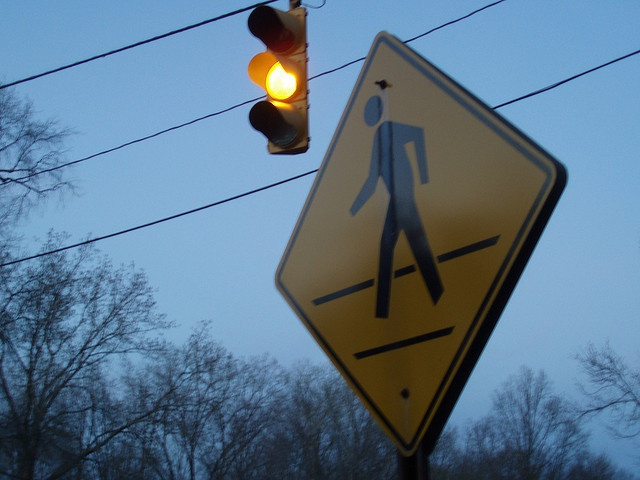Describe the objects in this image and their specific colors. I can see people in darkgray, black, darkblue, navy, and gray tones and traffic light in darkgray, black, maroon, brown, and ivory tones in this image. 